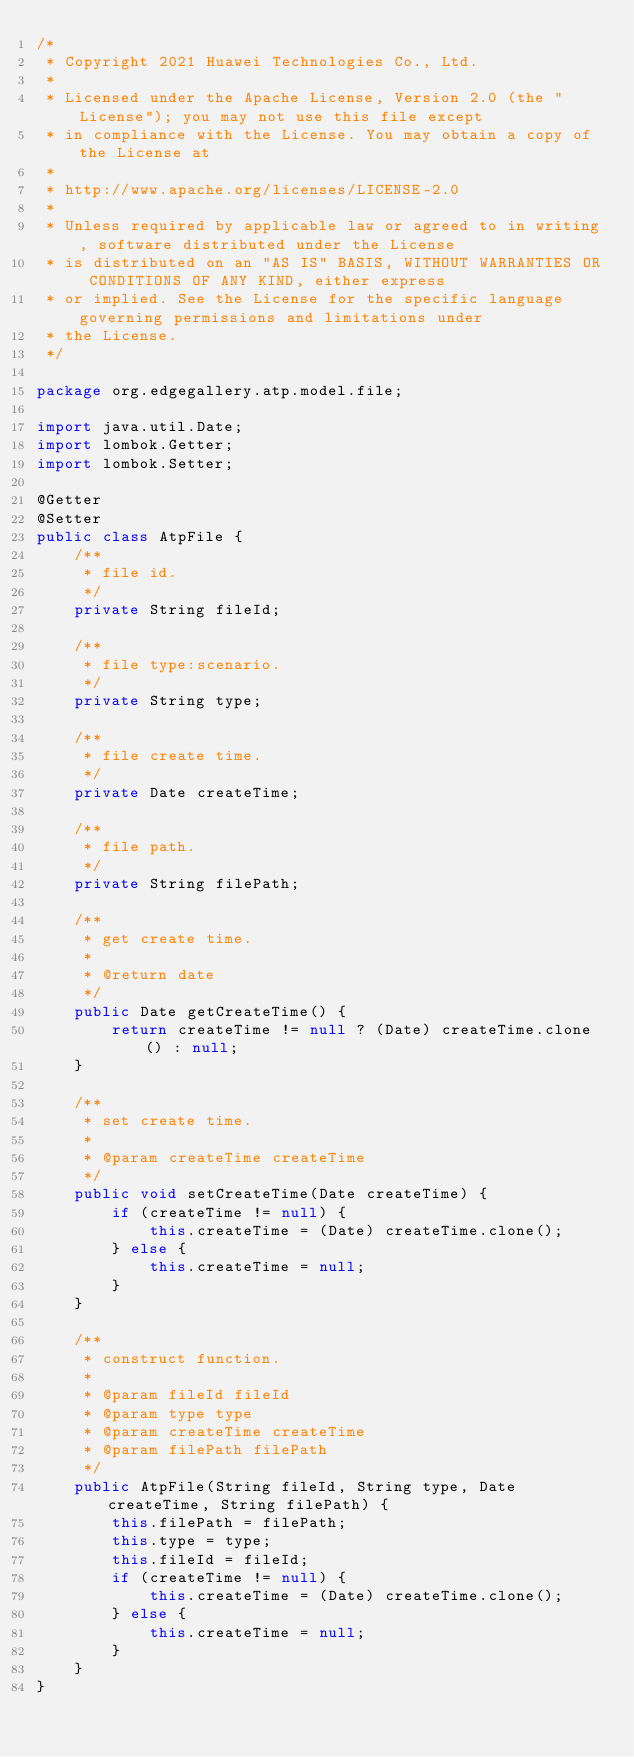<code> <loc_0><loc_0><loc_500><loc_500><_Java_>/*
 * Copyright 2021 Huawei Technologies Co., Ltd.
 *
 * Licensed under the Apache License, Version 2.0 (the "License"); you may not use this file except
 * in compliance with the License. You may obtain a copy of the License at
 *
 * http://www.apache.org/licenses/LICENSE-2.0
 *
 * Unless required by applicable law or agreed to in writing, software distributed under the License
 * is distributed on an "AS IS" BASIS, WITHOUT WARRANTIES OR CONDITIONS OF ANY KIND, either express
 * or implied. See the License for the specific language governing permissions and limitations under
 * the License.
 */

package org.edgegallery.atp.model.file;

import java.util.Date;
import lombok.Getter;
import lombok.Setter;

@Getter
@Setter
public class AtpFile {
    /**
     * file id.
     */
    private String fileId;

    /**
     * file type:scenario.
     */
    private String type;

    /**
     * file create time.
     */
    private Date createTime;

    /**
     * file path.
     */
    private String filePath;

    /**
     * get create time.
     * 
     * @return date
     */
    public Date getCreateTime() {
        return createTime != null ? (Date) createTime.clone() : null;
    }

    /**
     * set create time.
     * 
     * @param createTime createTime
     */
    public void setCreateTime(Date createTime) {
        if (createTime != null) {
            this.createTime = (Date) createTime.clone();
        } else {
            this.createTime = null;
        }
    }

    /**
     * construct function.
     * 
     * @param fileId fileId
     * @param type type
     * @param createTime createTime
     * @param filePath filePath
     */
    public AtpFile(String fileId, String type, Date createTime, String filePath) {
        this.filePath = filePath;
        this.type = type;
        this.fileId = fileId;
        if (createTime != null) {
            this.createTime = (Date) createTime.clone();
        } else {
            this.createTime = null;
        }
    }
}
</code> 